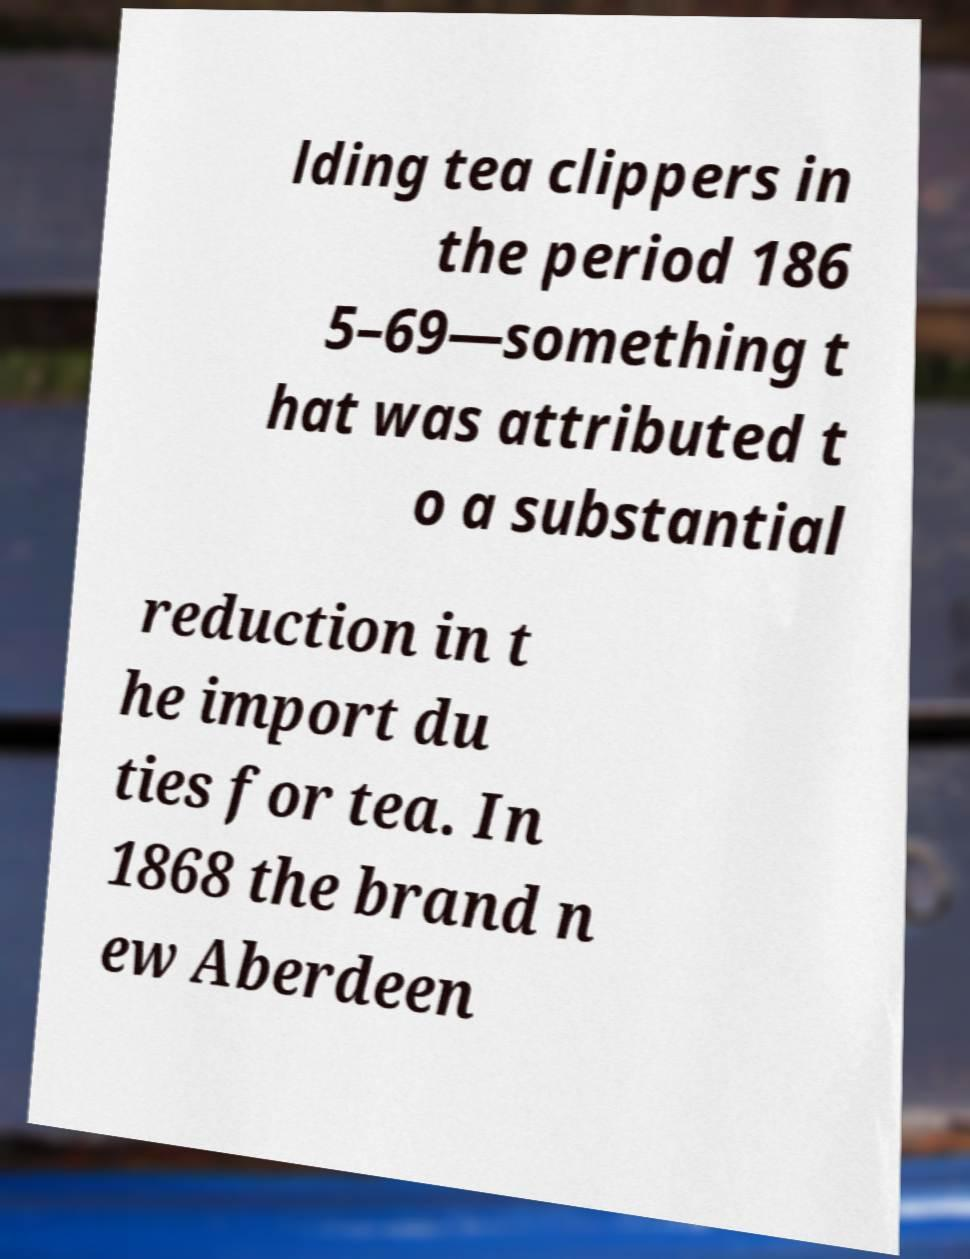I need the written content from this picture converted into text. Can you do that? lding tea clippers in the period 186 5–69—something t hat was attributed t o a substantial reduction in t he import du ties for tea. In 1868 the brand n ew Aberdeen 